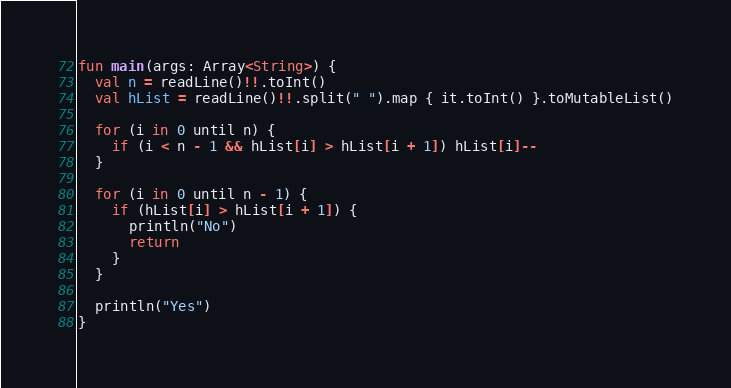<code> <loc_0><loc_0><loc_500><loc_500><_Kotlin_>fun main(args: Array<String>) {
  val n = readLine()!!.toInt()
  val hList = readLine()!!.split(" ").map { it.toInt() }.toMutableList()

  for (i in 0 until n) {
    if (i < n - 1 && hList[i] > hList[i + 1]) hList[i]--
  }

  for (i in 0 until n - 1) {
    if (hList[i] > hList[i + 1]) {
      println("No")
      return
    }
  }

  println("Yes")
}

</code> 